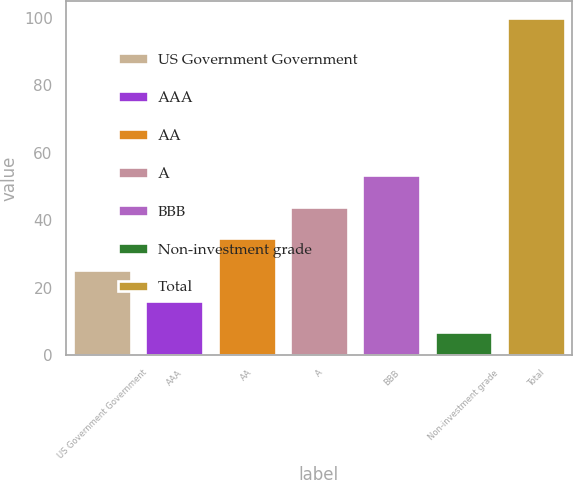Convert chart. <chart><loc_0><loc_0><loc_500><loc_500><bar_chart><fcel>US Government Government<fcel>AAA<fcel>AA<fcel>A<fcel>BBB<fcel>Non-investment grade<fcel>Total<nl><fcel>25.36<fcel>16.03<fcel>34.69<fcel>44.02<fcel>53.35<fcel>6.7<fcel>100<nl></chart> 